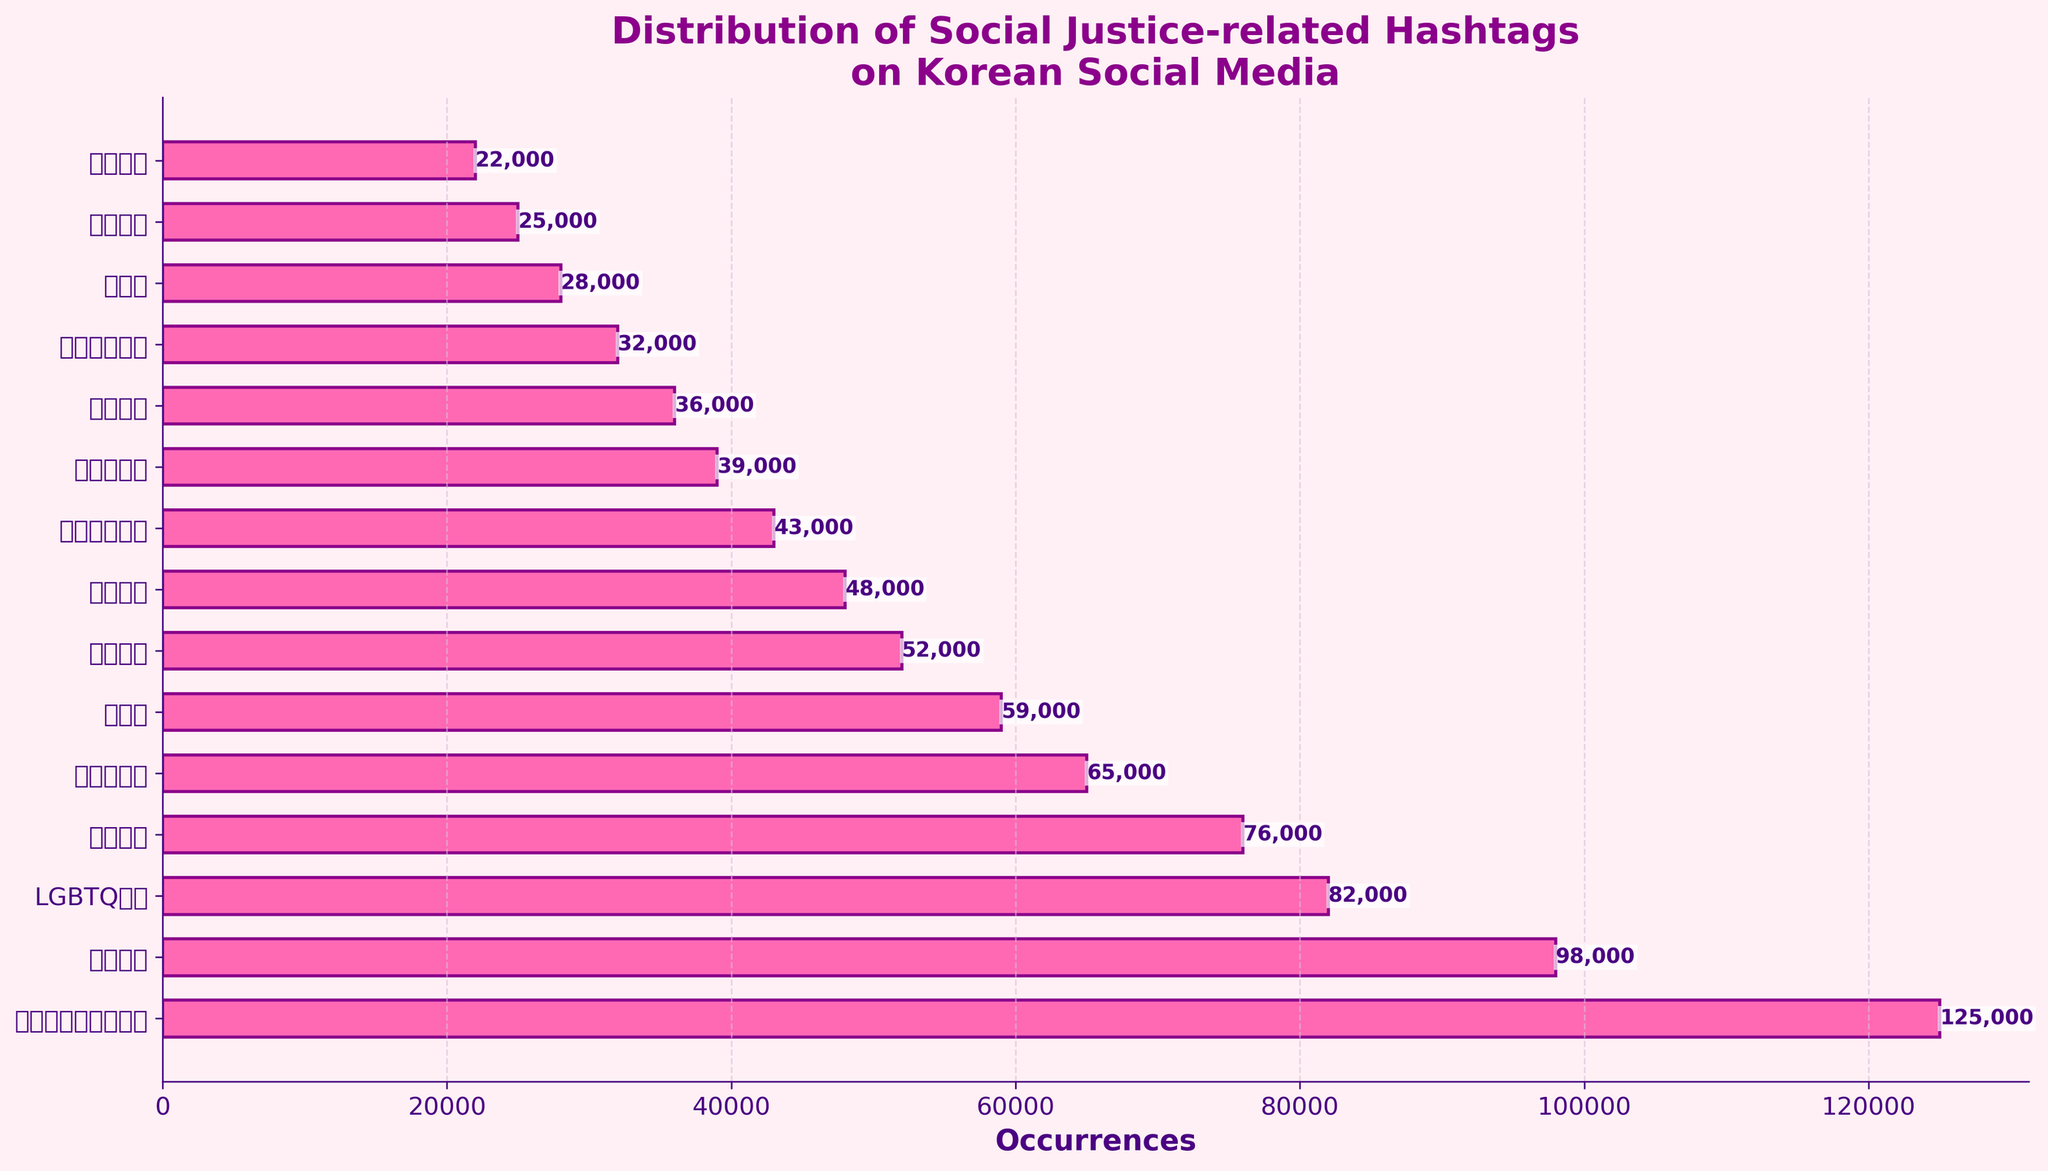What is the most common social justice-related hashtag? The hashtag with the highest occurrences represents the most common one. By looking at the bar chart, the bar with the longest length or highest value will give us the answer.
Answer: #흑인생명도소중하다 How many more occurrences does the #흑인생명도소중하다 hashtag have compared to the #젠더평등 hashtag? First, identify the occurrences of both hashtags from the figure. #흑인생명도소중하다 has 125,000 occurrences, and #젠더평등 has 25,000 occurrences. Subtract the smaller number from the larger one: 125,000 - 25,000.
Answer: 100,000 Which hashtag has the fewest occurrences? The hashtag with the shortest bar or the lowest value represents the one with the fewest occurrences.
Answer: #환경보호 How many occurrences are there in total for the three least frequent hashtags? Identify the three hashtags with the shortest bars: #환경보호 (22,000), #젠더평등 (25,000), and #동물권 (28,000). Sum their occurrences: 22,000 + 25,000 + 28,000.
Answer: 75,000 Compare the occurrences of #페미니즘 and #노동권. Which is more frequent and by how much? From the figure, #페미니즘 has 98,000 occurrences and #노동권 has 59,000 occurrences. Subtract the smaller number from the larger one: 98,000 - 59,000.
Answer: #페미니즘, 39,000 What’s the average number of occurrences of the hashtags shown in the figure? Add the occurrences of all hashtags and divide by the number of hashtags. Sum: 125,000 + 98,000 + 82,000 + 76,000 + 65,000 + 59,000 + 52,000 + 48,000 + 43,000 + 39,000 + 36,000 + 32,000 + 28,000 + 25,000 + 22,000 = 830,000. Divide by 15 hashtags: 830,000 / 15.
Answer: 55,333 Is the number of occurrences of #세월호기억 greater, less than, or equal to that of #양성평등? Compare the heights of the bars for #세월호기억 and #양성평등. #세월호기억 has 39,000 occurrences, and #양성평등 has 48,000 occurrences.
Answer: Less than Which hashtag related to sexual harassment or discrimination has the highest occurrences? Identify the related hashtags: #미투운동. Compare its occurrences with others. #미투운동 has 36,000 occurrences.
Answer: #미투운동 